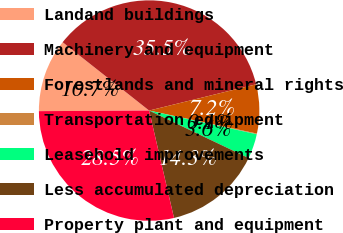Convert chart to OTSL. <chart><loc_0><loc_0><loc_500><loc_500><pie_chart><fcel>Landand buildings<fcel>Machinery and equipment<fcel>Forestlands and mineral rights<fcel>Transportation equipment<fcel>Leasehold improvements<fcel>Less accumulated depreciation<fcel>Property plant and equipment<nl><fcel>10.73%<fcel>35.53%<fcel>7.18%<fcel>0.1%<fcel>3.64%<fcel>14.29%<fcel>28.54%<nl></chart> 